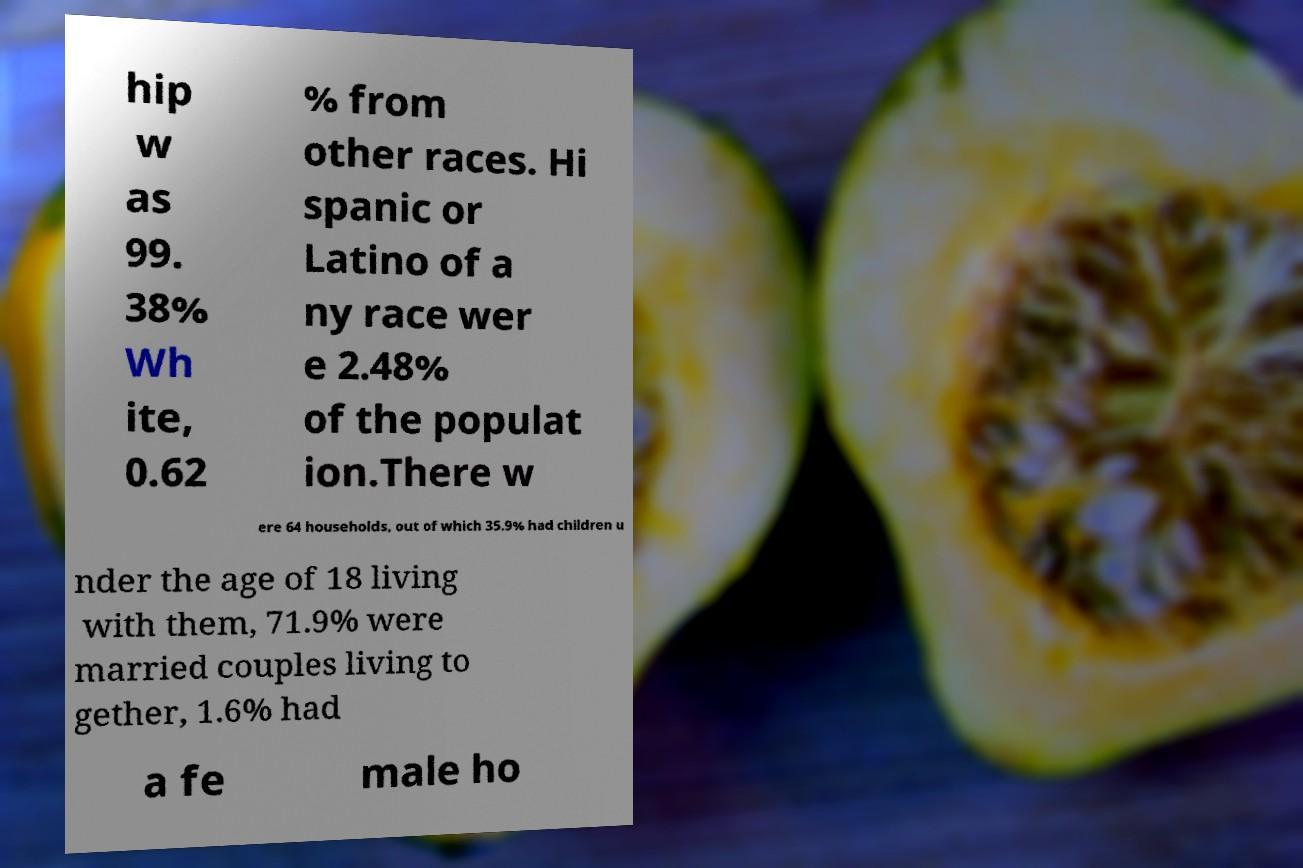For documentation purposes, I need the text within this image transcribed. Could you provide that? hip w as 99. 38% Wh ite, 0.62 % from other races. Hi spanic or Latino of a ny race wer e 2.48% of the populat ion.There w ere 64 households, out of which 35.9% had children u nder the age of 18 living with them, 71.9% were married couples living to gether, 1.6% had a fe male ho 